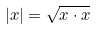<formula> <loc_0><loc_0><loc_500><loc_500>| x | = \sqrt { x \cdot x }</formula> 